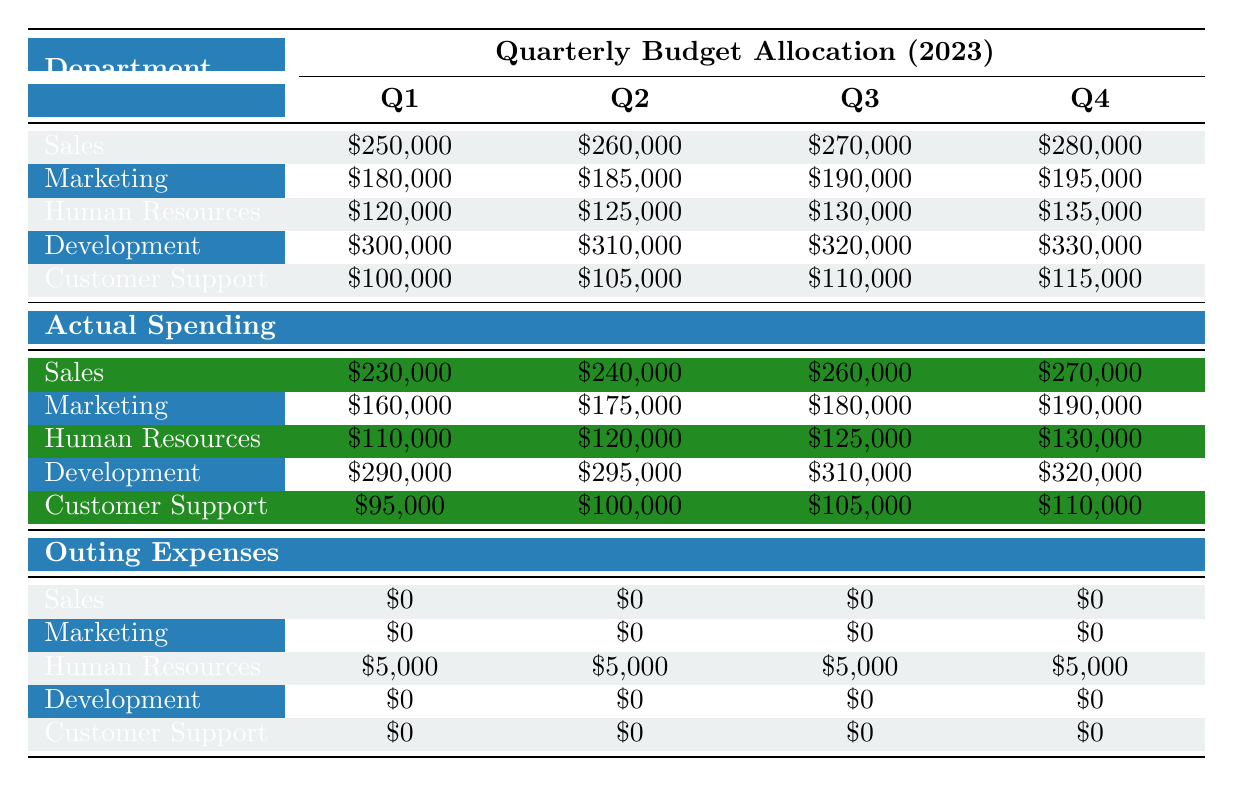What is the total budget allocated to the Sales department in Q4 2023? The budget allocated to the Sales department in Q4 2023 is directly stated in the table as $280,000.
Answer: $280,000 How much did the Human Resources department spend in Q2 2023? The spending for the Human Resources department in Q2 2023 is listed in the table as $120,000.
Answer: $120,000 Which department had the highest outing expenses in Q1 2023? By checking the outing expenses for each department in Q1 2023, Human Resources with $5,000 is the only one with outing expenses, while others have $0. Thus, Human Resources had the highest outing expenses.
Answer: Human Resources What was the total spending by the Development department across all four quarters? The total spending by the Development department can be calculated by summing the expenses: $290,000 (Q1) + $295,000 (Q2) + $310,000 (Q3) + $320,000 (Q4) = $1,215,000.
Answer: $1,215,000 Is it true that Marketing spent more than $170,000 in Q2 2023? The table shows that Marketing spent $175,000 in Q2 2023, which is indeed more than $170,000.
Answer: Yes What is the percentage of the remaining budget for Customer Support in Q3 2023 relative to its allocated budget? The remaining budget for Customer Support in Q3 2023 is $5,000, and the allocated budget was $110,000. The percentage is calculated as ($5,000 / $110,000) * 100, which equals approximately 4.55%.
Answer: 4.55% In which quarter did the Sales department have the least difference between allocated budget and actual spending? For Sales, the differences are: $250,000 - $230,000 = $20,000 (Q1), $260,000 - $240,000 = $20,000 (Q2), $270,000 - $260,000 = $10,000 (Q3), and $280,000 - $270,000 = $10,000 (Q4). Since Q3 and Q4 both have the least difference, we consider the first occurrence. Thus, the Sales department had the least difference in Q3 2023.
Answer: Q3 2023 Which department consistently reported zero outing expenses throughout 2023? By examining the outing expenses for each department across all quarters, Sales, Marketing, Development, and Customer Support all reported $0 for outing expenses throughout the year, meaning they consistently have no outing expenses.
Answer: Sales, Marketing, Development, Customer Support What is the average outing expense for the Human Resources department over 2023? The outing expense for Human Resources is $5,000 in each quarter, totaling $5,000 * 4 = $20,000. The average is $20,000 / 4 = $5,000.
Answer: $5,000 